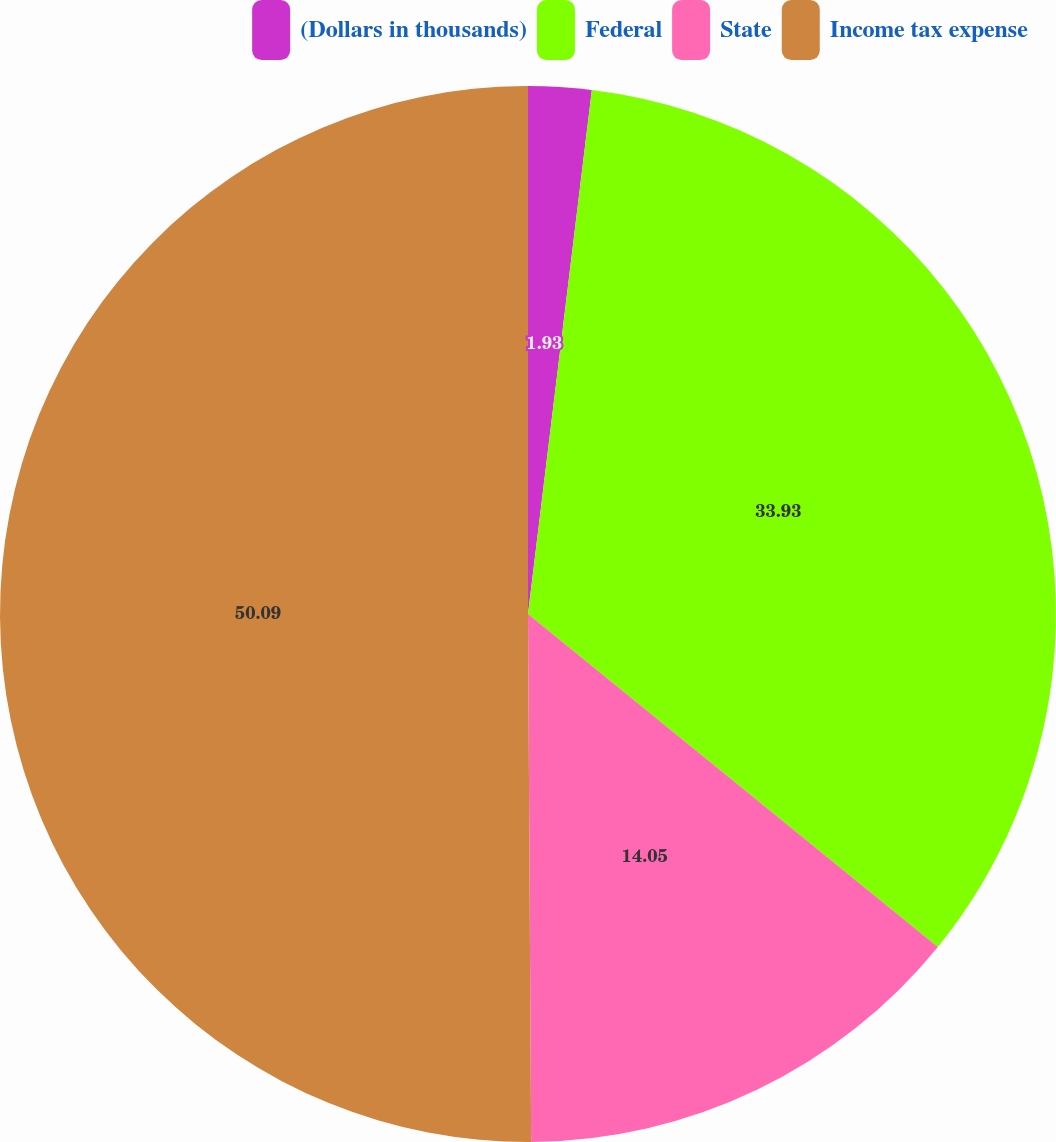Convert chart. <chart><loc_0><loc_0><loc_500><loc_500><pie_chart><fcel>(Dollars in thousands)<fcel>Federal<fcel>State<fcel>Income tax expense<nl><fcel>1.93%<fcel>33.93%<fcel>14.05%<fcel>50.1%<nl></chart> 